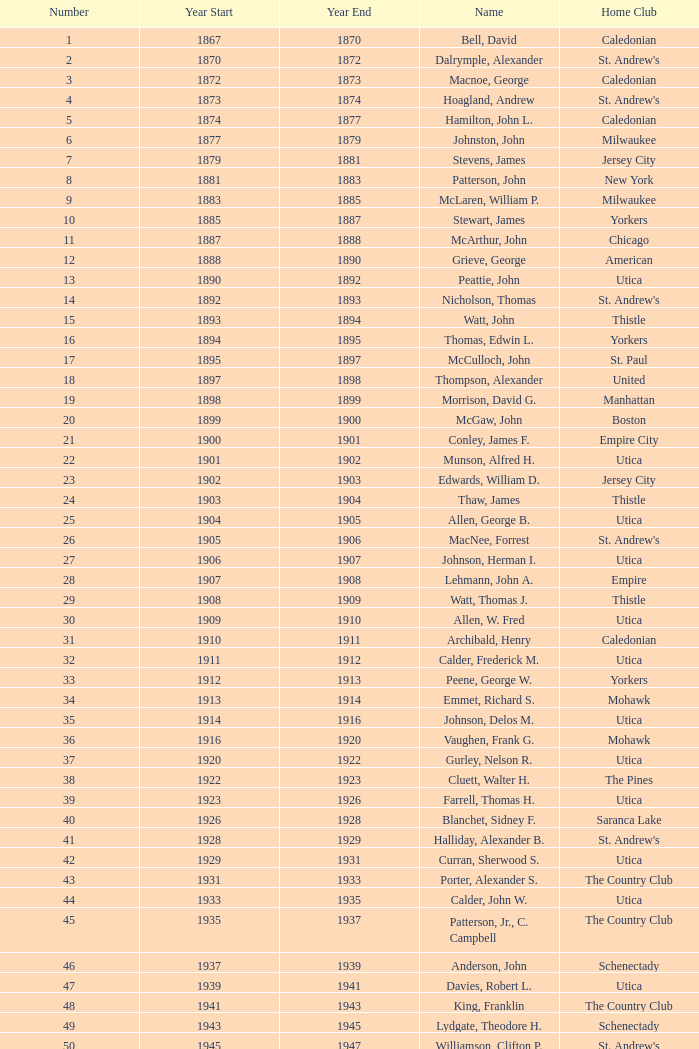Which Number has a Name of cooper, c. kenneth, and a Year End larger than 1984? None. 